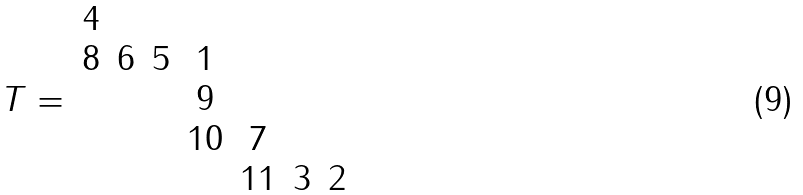Convert formula to latex. <formula><loc_0><loc_0><loc_500><loc_500>T = \begin{array} { c c c c c c c } 4 & & & & & & \\ 8 & 6 & 5 & 1 & & & \\ & & & 9 & & & \\ & & & 1 0 & 7 & & \\ & & & & 1 1 & 3 & 2 \end{array}</formula> 